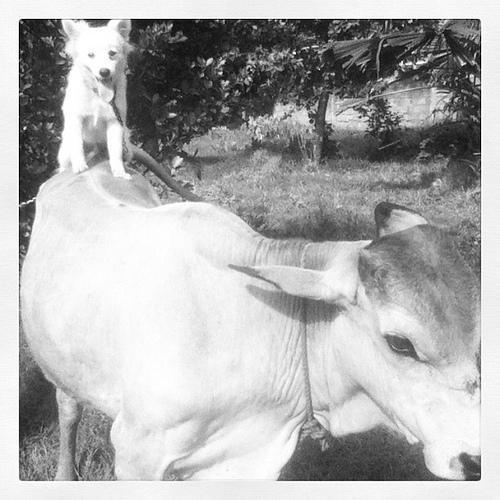How many dogs are in the picture?
Give a very brief answer. 1. 